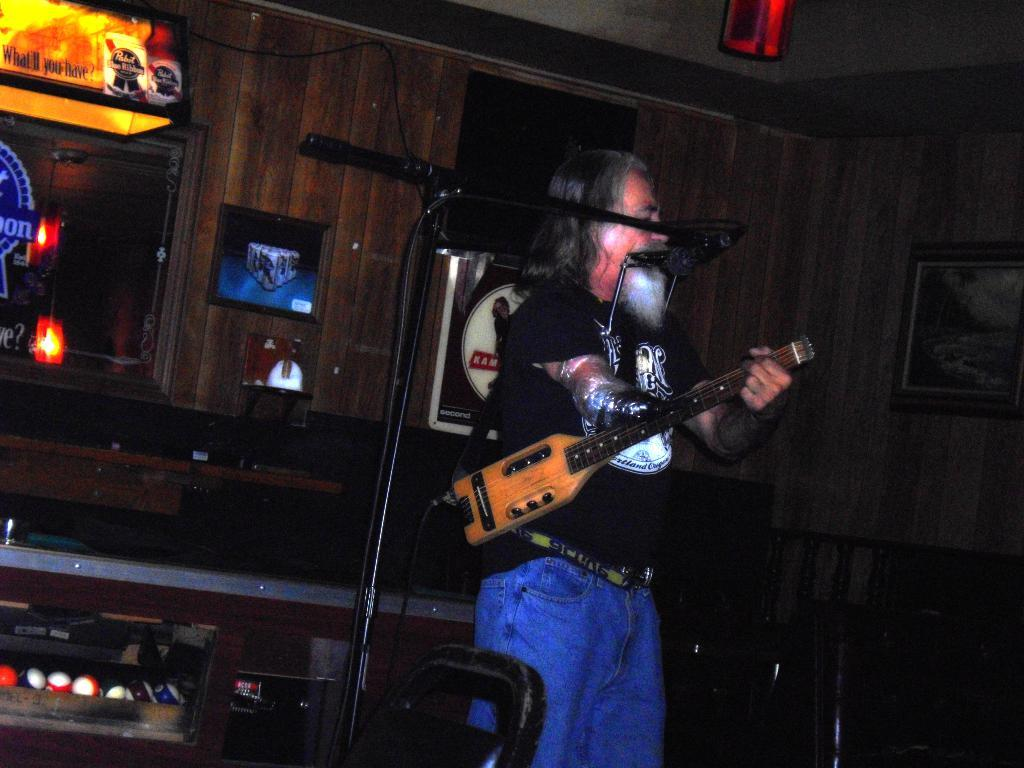<image>
Create a compact narrative representing the image presented. A bar with a light that has what'll you have? wrote on it 